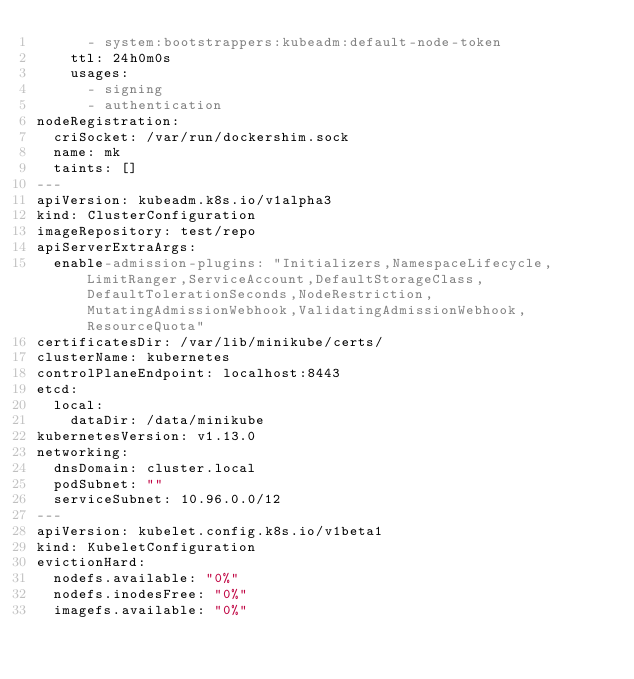Convert code to text. <code><loc_0><loc_0><loc_500><loc_500><_YAML_>      - system:bootstrappers:kubeadm:default-node-token
    ttl: 24h0m0s
    usages:
      - signing
      - authentication
nodeRegistration:
  criSocket: /var/run/dockershim.sock
  name: mk
  taints: []
---
apiVersion: kubeadm.k8s.io/v1alpha3
kind: ClusterConfiguration
imageRepository: test/repo
apiServerExtraArgs:
  enable-admission-plugins: "Initializers,NamespaceLifecycle,LimitRanger,ServiceAccount,DefaultStorageClass,DefaultTolerationSeconds,NodeRestriction,MutatingAdmissionWebhook,ValidatingAdmissionWebhook,ResourceQuota"
certificatesDir: /var/lib/minikube/certs/
clusterName: kubernetes
controlPlaneEndpoint: localhost:8443
etcd:
  local:
    dataDir: /data/minikube
kubernetesVersion: v1.13.0
networking:
  dnsDomain: cluster.local
  podSubnet: ""
  serviceSubnet: 10.96.0.0/12
---
apiVersion: kubelet.config.k8s.io/v1beta1
kind: KubeletConfiguration
evictionHard:
  nodefs.available: "0%"
  nodefs.inodesFree: "0%"
  imagefs.available: "0%"
</code> 